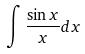Convert formula to latex. <formula><loc_0><loc_0><loc_500><loc_500>\int \frac { \sin x } { x } d x</formula> 